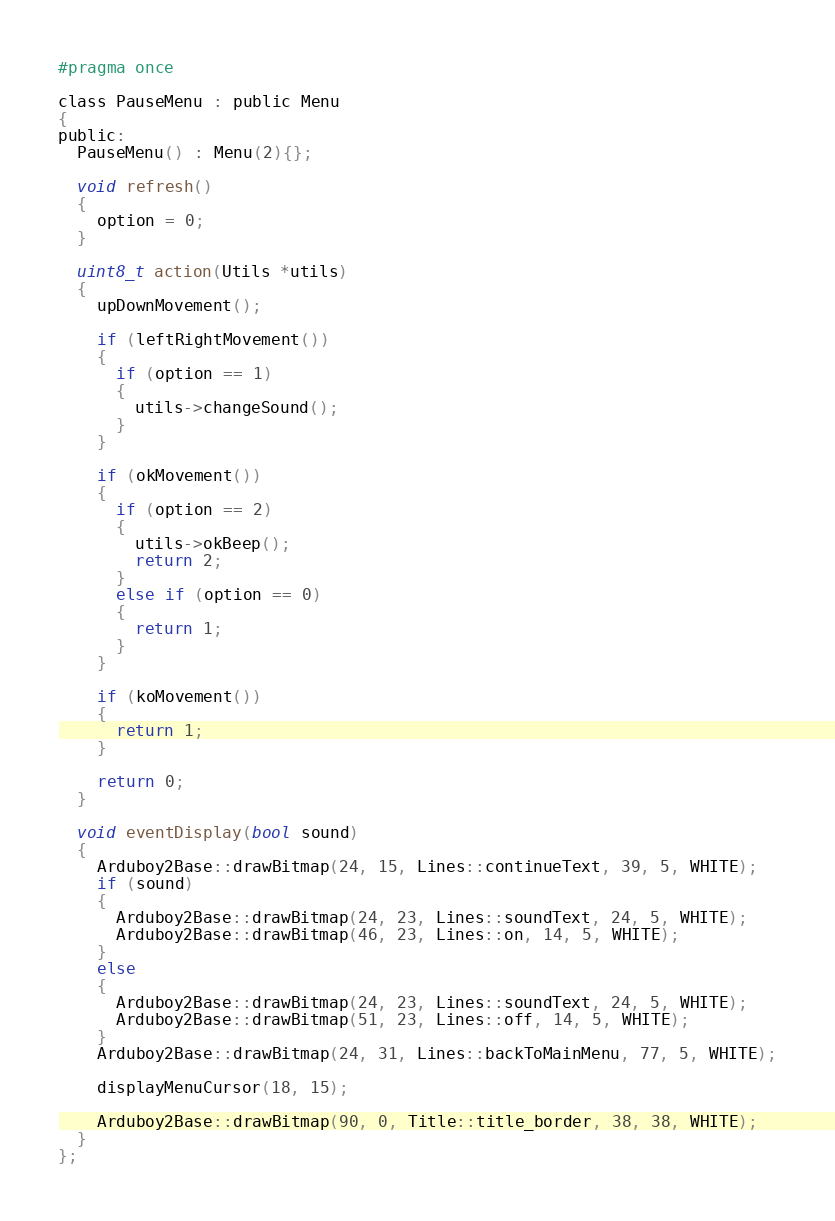<code> <loc_0><loc_0><loc_500><loc_500><_C_>#pragma once

class PauseMenu : public Menu
{
public:
  PauseMenu() : Menu(2){};

  void refresh()
  {
    option = 0;
  }

  uint8_t action(Utils *utils)
  {
    upDownMovement();

    if (leftRightMovement())
    {
      if (option == 1)
      {
        utils->changeSound();
      }
    }

    if (okMovement())
    {
      if (option == 2)
      {
        utils->okBeep();
        return 2;
      }
      else if (option == 0)
      {
        return 1;
      }
    }

    if (koMovement())
    {
      return 1;
    }

    return 0;
  }

  void eventDisplay(bool sound)
  {
    Arduboy2Base::drawBitmap(24, 15, Lines::continueText, 39, 5, WHITE);
    if (sound)
    {
      Arduboy2Base::drawBitmap(24, 23, Lines::soundText, 24, 5, WHITE);
      Arduboy2Base::drawBitmap(46, 23, Lines::on, 14, 5, WHITE);
    }
    else
    {
      Arduboy2Base::drawBitmap(24, 23, Lines::soundText, 24, 5, WHITE);
      Arduboy2Base::drawBitmap(51, 23, Lines::off, 14, 5, WHITE);
    }
    Arduboy2Base::drawBitmap(24, 31, Lines::backToMainMenu, 77, 5, WHITE);

    displayMenuCursor(18, 15);

    Arduboy2Base::drawBitmap(90, 0, Title::title_border, 38, 38, WHITE);
  }
};
</code> 